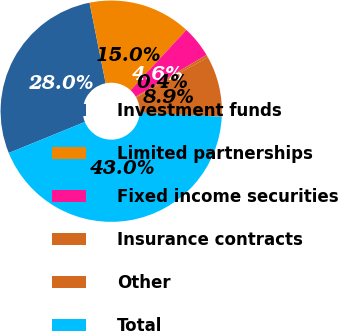Convert chart. <chart><loc_0><loc_0><loc_500><loc_500><pie_chart><fcel>Investment funds<fcel>Limited partnerships<fcel>Fixed income securities<fcel>Insurance contracts<fcel>Other<fcel>Total<nl><fcel>28.03%<fcel>15.01%<fcel>4.64%<fcel>0.38%<fcel>8.91%<fcel>43.04%<nl></chart> 